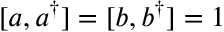Convert formula to latex. <formula><loc_0><loc_0><loc_500><loc_500>[ a , a ^ { \dagger } ] = [ b , b ^ { \dagger } ] = 1</formula> 